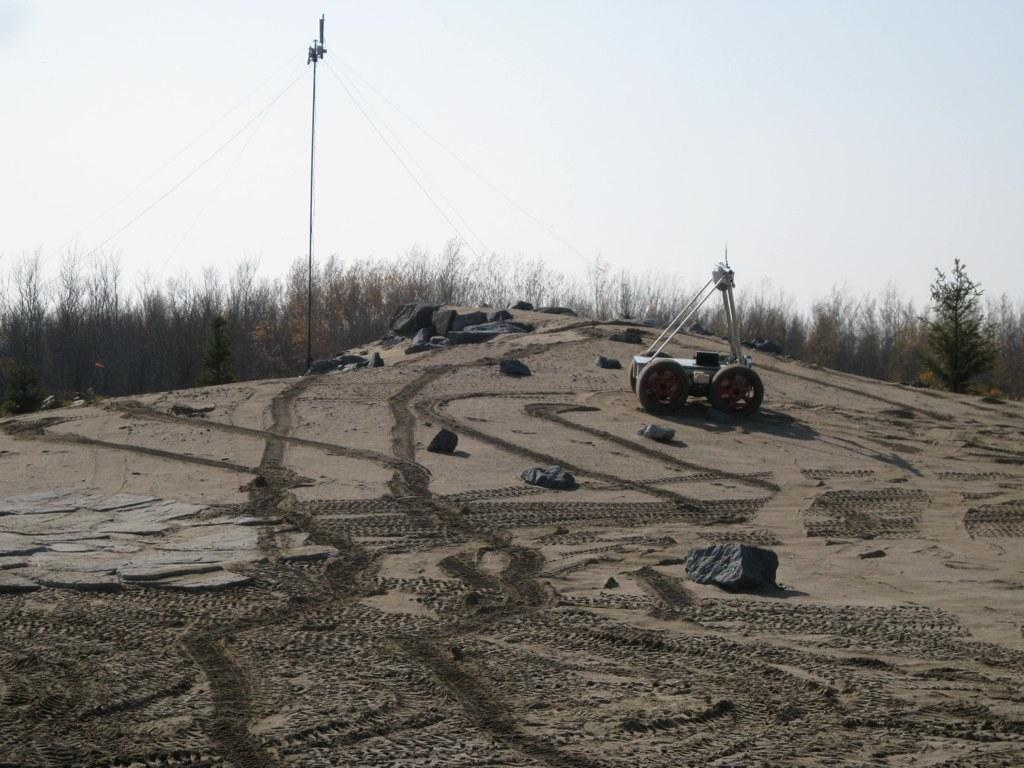What is the main object in the image? There is an object in the image, but its specific nature is not mentioned in the facts. What can be seen on the sand in the image? There are rocks on the surface of the sand in the image. What is visible in the background of the image? There are trees, a utility pole, and the sky visible in the background of the image. Where is the market located in the image? There is no mention of a market in the image or the provided facts. 